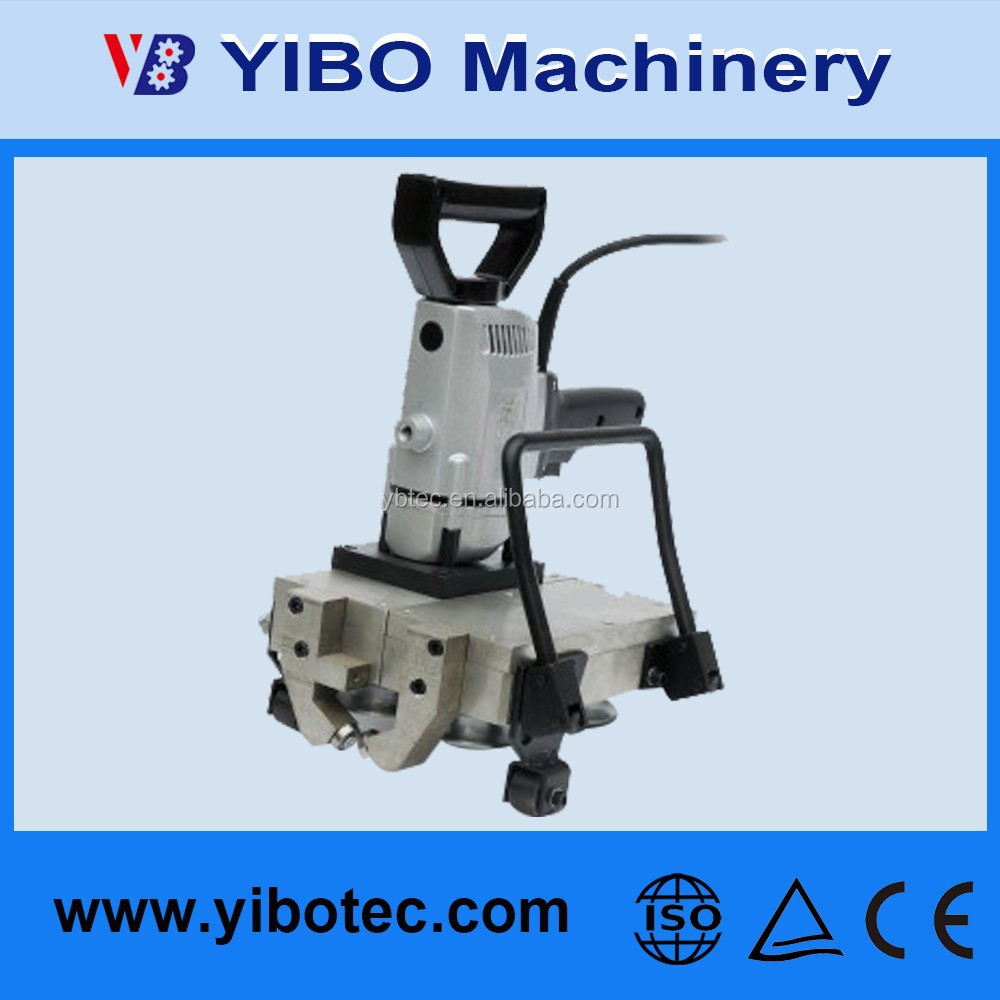Describe a long realistic scenario where this machine is crucial in a construction site. At a large construction site, workers are tasked with erecting a new skyscraper. This machine plays a pivotal role in the metal fabrication shop set up on-site. Throughout the day, the machine is used to cut, shape, and prepare steel beams and metal panels to precise specifications required for the building's framework. The machine's rugged design and high compliance with safety standards make it ideal for the tough environment of the construction site. Operators feed metal sheets into the machine, which cuts them with high accuracy and speed, minimizing material waste and ensuring that each piece fits perfectly into the construction plan. Beyond its cutting duties, the machine also engraves identification numbers and safety information onto each component, maintaining proper tracking and regulatory compliance. The site manager frequently checks the machine's performance through its diagnostic display, ensuring it operates smoothly and safely. The efficient use of this machinery accelerates the construction process, ensuring the project stays on schedule and within budget. 